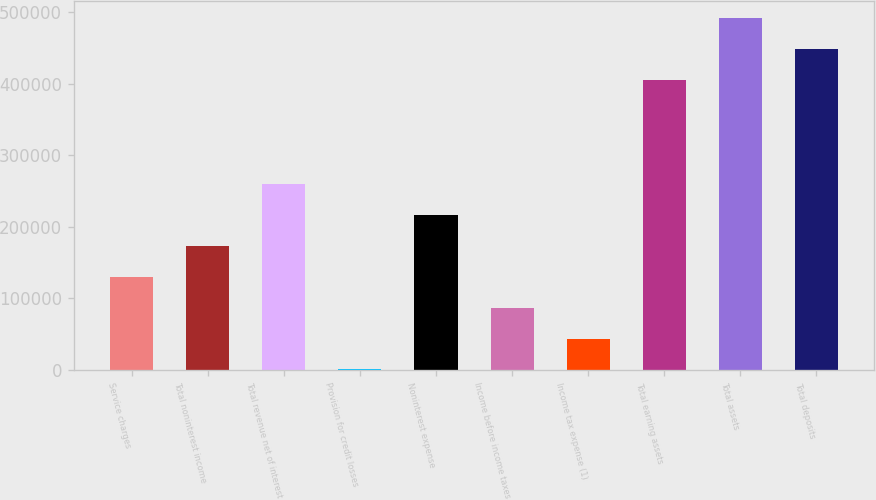Convert chart to OTSL. <chart><loc_0><loc_0><loc_500><loc_500><bar_chart><fcel>Service charges<fcel>Total noninterest income<fcel>Total revenue net of interest<fcel>Provision for credit losses<fcel>Noninterest expense<fcel>Income before income taxes<fcel>Income tax expense (1)<fcel>Total earning assets<fcel>Total assets<fcel>Total deposits<nl><fcel>129709<fcel>172831<fcel>259076<fcel>343<fcel>215954<fcel>86587.2<fcel>43465.1<fcel>405104<fcel>491348<fcel>448226<nl></chart> 